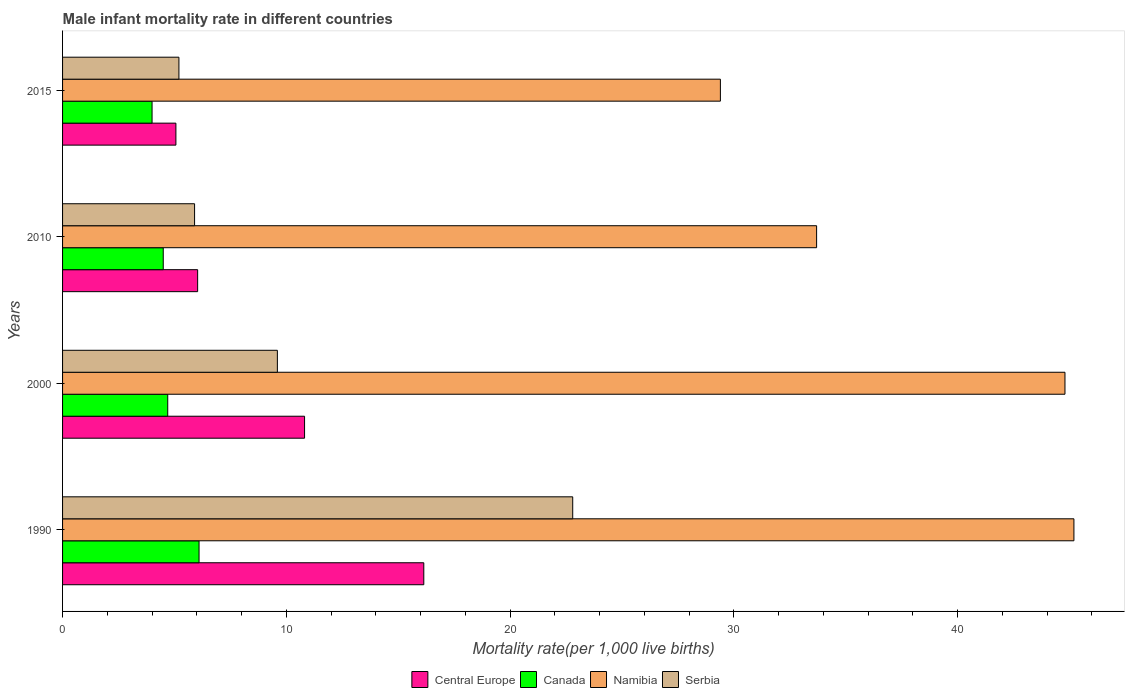How many groups of bars are there?
Make the answer very short. 4. What is the label of the 4th group of bars from the top?
Your response must be concise. 1990. What is the male infant mortality rate in Serbia in 2000?
Give a very brief answer. 9.6. Across all years, what is the maximum male infant mortality rate in Central Europe?
Provide a short and direct response. 16.14. Across all years, what is the minimum male infant mortality rate in Namibia?
Your response must be concise. 29.4. In which year was the male infant mortality rate in Namibia minimum?
Give a very brief answer. 2015. What is the total male infant mortality rate in Canada in the graph?
Your answer should be very brief. 19.3. What is the difference between the male infant mortality rate in Serbia in 2000 and that in 2015?
Provide a short and direct response. 4.4. What is the average male infant mortality rate in Serbia per year?
Ensure brevity in your answer.  10.88. In the year 2000, what is the difference between the male infant mortality rate in Serbia and male infant mortality rate in Namibia?
Your answer should be compact. -35.2. What is the ratio of the male infant mortality rate in Namibia in 1990 to that in 2000?
Your answer should be very brief. 1.01. Is the difference between the male infant mortality rate in Serbia in 1990 and 2015 greater than the difference between the male infant mortality rate in Namibia in 1990 and 2015?
Make the answer very short. Yes. What is the difference between the highest and the second highest male infant mortality rate in Central Europe?
Provide a succinct answer. 5.33. What is the difference between the highest and the lowest male infant mortality rate in Canada?
Make the answer very short. 2.1. Is the sum of the male infant mortality rate in Namibia in 1990 and 2000 greater than the maximum male infant mortality rate in Serbia across all years?
Provide a short and direct response. Yes. What does the 4th bar from the top in 2000 represents?
Offer a terse response. Central Europe. What does the 4th bar from the bottom in 2015 represents?
Provide a succinct answer. Serbia. How many bars are there?
Ensure brevity in your answer.  16. What is the difference between two consecutive major ticks on the X-axis?
Give a very brief answer. 10. Are the values on the major ticks of X-axis written in scientific E-notation?
Your answer should be compact. No. How many legend labels are there?
Provide a succinct answer. 4. What is the title of the graph?
Offer a very short reply. Male infant mortality rate in different countries. What is the label or title of the X-axis?
Provide a succinct answer. Mortality rate(per 1,0 live births). What is the label or title of the Y-axis?
Your response must be concise. Years. What is the Mortality rate(per 1,000 live births) in Central Europe in 1990?
Your answer should be very brief. 16.14. What is the Mortality rate(per 1,000 live births) of Namibia in 1990?
Provide a succinct answer. 45.2. What is the Mortality rate(per 1,000 live births) in Serbia in 1990?
Provide a succinct answer. 22.8. What is the Mortality rate(per 1,000 live births) in Central Europe in 2000?
Make the answer very short. 10.82. What is the Mortality rate(per 1,000 live births) in Canada in 2000?
Make the answer very short. 4.7. What is the Mortality rate(per 1,000 live births) in Namibia in 2000?
Give a very brief answer. 44.8. What is the Mortality rate(per 1,000 live births) in Serbia in 2000?
Offer a very short reply. 9.6. What is the Mortality rate(per 1,000 live births) in Central Europe in 2010?
Make the answer very short. 6.04. What is the Mortality rate(per 1,000 live births) of Namibia in 2010?
Keep it short and to the point. 33.7. What is the Mortality rate(per 1,000 live births) of Serbia in 2010?
Ensure brevity in your answer.  5.9. What is the Mortality rate(per 1,000 live births) of Central Europe in 2015?
Offer a very short reply. 5.07. What is the Mortality rate(per 1,000 live births) of Namibia in 2015?
Ensure brevity in your answer.  29.4. What is the Mortality rate(per 1,000 live births) of Serbia in 2015?
Make the answer very short. 5.2. Across all years, what is the maximum Mortality rate(per 1,000 live births) in Central Europe?
Ensure brevity in your answer.  16.14. Across all years, what is the maximum Mortality rate(per 1,000 live births) of Canada?
Ensure brevity in your answer.  6.1. Across all years, what is the maximum Mortality rate(per 1,000 live births) of Namibia?
Your answer should be compact. 45.2. Across all years, what is the maximum Mortality rate(per 1,000 live births) in Serbia?
Your answer should be very brief. 22.8. Across all years, what is the minimum Mortality rate(per 1,000 live births) in Central Europe?
Provide a succinct answer. 5.07. Across all years, what is the minimum Mortality rate(per 1,000 live births) of Namibia?
Make the answer very short. 29.4. What is the total Mortality rate(per 1,000 live births) in Central Europe in the graph?
Ensure brevity in your answer.  38.06. What is the total Mortality rate(per 1,000 live births) in Canada in the graph?
Your answer should be very brief. 19.3. What is the total Mortality rate(per 1,000 live births) of Namibia in the graph?
Your answer should be compact. 153.1. What is the total Mortality rate(per 1,000 live births) in Serbia in the graph?
Make the answer very short. 43.5. What is the difference between the Mortality rate(per 1,000 live births) in Central Europe in 1990 and that in 2000?
Ensure brevity in your answer.  5.33. What is the difference between the Mortality rate(per 1,000 live births) of Canada in 1990 and that in 2000?
Keep it short and to the point. 1.4. What is the difference between the Mortality rate(per 1,000 live births) in Central Europe in 1990 and that in 2010?
Keep it short and to the point. 10.11. What is the difference between the Mortality rate(per 1,000 live births) in Canada in 1990 and that in 2010?
Provide a short and direct response. 1.6. What is the difference between the Mortality rate(per 1,000 live births) in Namibia in 1990 and that in 2010?
Offer a very short reply. 11.5. What is the difference between the Mortality rate(per 1,000 live births) in Serbia in 1990 and that in 2010?
Make the answer very short. 16.9. What is the difference between the Mortality rate(per 1,000 live births) in Central Europe in 1990 and that in 2015?
Give a very brief answer. 11.08. What is the difference between the Mortality rate(per 1,000 live births) in Serbia in 1990 and that in 2015?
Ensure brevity in your answer.  17.6. What is the difference between the Mortality rate(per 1,000 live births) of Central Europe in 2000 and that in 2010?
Your response must be concise. 4.78. What is the difference between the Mortality rate(per 1,000 live births) in Canada in 2000 and that in 2010?
Ensure brevity in your answer.  0.2. What is the difference between the Mortality rate(per 1,000 live births) of Namibia in 2000 and that in 2010?
Your answer should be very brief. 11.1. What is the difference between the Mortality rate(per 1,000 live births) in Serbia in 2000 and that in 2010?
Ensure brevity in your answer.  3.7. What is the difference between the Mortality rate(per 1,000 live births) of Central Europe in 2000 and that in 2015?
Give a very brief answer. 5.75. What is the difference between the Mortality rate(per 1,000 live births) of Canada in 2000 and that in 2015?
Your response must be concise. 0.7. What is the difference between the Mortality rate(per 1,000 live births) of Namibia in 2000 and that in 2015?
Provide a succinct answer. 15.4. What is the difference between the Mortality rate(per 1,000 live births) in Serbia in 2000 and that in 2015?
Your answer should be very brief. 4.4. What is the difference between the Mortality rate(per 1,000 live births) in Central Europe in 2010 and that in 2015?
Offer a very short reply. 0.97. What is the difference between the Mortality rate(per 1,000 live births) of Central Europe in 1990 and the Mortality rate(per 1,000 live births) of Canada in 2000?
Ensure brevity in your answer.  11.44. What is the difference between the Mortality rate(per 1,000 live births) in Central Europe in 1990 and the Mortality rate(per 1,000 live births) in Namibia in 2000?
Give a very brief answer. -28.66. What is the difference between the Mortality rate(per 1,000 live births) of Central Europe in 1990 and the Mortality rate(per 1,000 live births) of Serbia in 2000?
Your answer should be very brief. 6.54. What is the difference between the Mortality rate(per 1,000 live births) of Canada in 1990 and the Mortality rate(per 1,000 live births) of Namibia in 2000?
Offer a very short reply. -38.7. What is the difference between the Mortality rate(per 1,000 live births) in Namibia in 1990 and the Mortality rate(per 1,000 live births) in Serbia in 2000?
Keep it short and to the point. 35.6. What is the difference between the Mortality rate(per 1,000 live births) of Central Europe in 1990 and the Mortality rate(per 1,000 live births) of Canada in 2010?
Provide a succinct answer. 11.64. What is the difference between the Mortality rate(per 1,000 live births) in Central Europe in 1990 and the Mortality rate(per 1,000 live births) in Namibia in 2010?
Give a very brief answer. -17.56. What is the difference between the Mortality rate(per 1,000 live births) in Central Europe in 1990 and the Mortality rate(per 1,000 live births) in Serbia in 2010?
Offer a very short reply. 10.24. What is the difference between the Mortality rate(per 1,000 live births) in Canada in 1990 and the Mortality rate(per 1,000 live births) in Namibia in 2010?
Keep it short and to the point. -27.6. What is the difference between the Mortality rate(per 1,000 live births) of Namibia in 1990 and the Mortality rate(per 1,000 live births) of Serbia in 2010?
Offer a very short reply. 39.3. What is the difference between the Mortality rate(per 1,000 live births) of Central Europe in 1990 and the Mortality rate(per 1,000 live births) of Canada in 2015?
Your answer should be very brief. 12.14. What is the difference between the Mortality rate(per 1,000 live births) of Central Europe in 1990 and the Mortality rate(per 1,000 live births) of Namibia in 2015?
Ensure brevity in your answer.  -13.26. What is the difference between the Mortality rate(per 1,000 live births) of Central Europe in 1990 and the Mortality rate(per 1,000 live births) of Serbia in 2015?
Give a very brief answer. 10.94. What is the difference between the Mortality rate(per 1,000 live births) of Canada in 1990 and the Mortality rate(per 1,000 live births) of Namibia in 2015?
Offer a terse response. -23.3. What is the difference between the Mortality rate(per 1,000 live births) of Central Europe in 2000 and the Mortality rate(per 1,000 live births) of Canada in 2010?
Your answer should be compact. 6.32. What is the difference between the Mortality rate(per 1,000 live births) of Central Europe in 2000 and the Mortality rate(per 1,000 live births) of Namibia in 2010?
Give a very brief answer. -22.88. What is the difference between the Mortality rate(per 1,000 live births) of Central Europe in 2000 and the Mortality rate(per 1,000 live births) of Serbia in 2010?
Keep it short and to the point. 4.92. What is the difference between the Mortality rate(per 1,000 live births) in Canada in 2000 and the Mortality rate(per 1,000 live births) in Serbia in 2010?
Provide a short and direct response. -1.2. What is the difference between the Mortality rate(per 1,000 live births) in Namibia in 2000 and the Mortality rate(per 1,000 live births) in Serbia in 2010?
Your answer should be compact. 38.9. What is the difference between the Mortality rate(per 1,000 live births) of Central Europe in 2000 and the Mortality rate(per 1,000 live births) of Canada in 2015?
Provide a succinct answer. 6.82. What is the difference between the Mortality rate(per 1,000 live births) of Central Europe in 2000 and the Mortality rate(per 1,000 live births) of Namibia in 2015?
Offer a terse response. -18.58. What is the difference between the Mortality rate(per 1,000 live births) of Central Europe in 2000 and the Mortality rate(per 1,000 live births) of Serbia in 2015?
Your answer should be very brief. 5.62. What is the difference between the Mortality rate(per 1,000 live births) in Canada in 2000 and the Mortality rate(per 1,000 live births) in Namibia in 2015?
Offer a terse response. -24.7. What is the difference between the Mortality rate(per 1,000 live births) of Namibia in 2000 and the Mortality rate(per 1,000 live births) of Serbia in 2015?
Keep it short and to the point. 39.6. What is the difference between the Mortality rate(per 1,000 live births) in Central Europe in 2010 and the Mortality rate(per 1,000 live births) in Canada in 2015?
Provide a short and direct response. 2.04. What is the difference between the Mortality rate(per 1,000 live births) of Central Europe in 2010 and the Mortality rate(per 1,000 live births) of Namibia in 2015?
Give a very brief answer. -23.36. What is the difference between the Mortality rate(per 1,000 live births) of Central Europe in 2010 and the Mortality rate(per 1,000 live births) of Serbia in 2015?
Give a very brief answer. 0.84. What is the difference between the Mortality rate(per 1,000 live births) of Canada in 2010 and the Mortality rate(per 1,000 live births) of Namibia in 2015?
Keep it short and to the point. -24.9. What is the difference between the Mortality rate(per 1,000 live births) of Namibia in 2010 and the Mortality rate(per 1,000 live births) of Serbia in 2015?
Your answer should be compact. 28.5. What is the average Mortality rate(per 1,000 live births) in Central Europe per year?
Offer a very short reply. 9.52. What is the average Mortality rate(per 1,000 live births) in Canada per year?
Make the answer very short. 4.83. What is the average Mortality rate(per 1,000 live births) of Namibia per year?
Keep it short and to the point. 38.27. What is the average Mortality rate(per 1,000 live births) in Serbia per year?
Keep it short and to the point. 10.88. In the year 1990, what is the difference between the Mortality rate(per 1,000 live births) of Central Europe and Mortality rate(per 1,000 live births) of Canada?
Your response must be concise. 10.04. In the year 1990, what is the difference between the Mortality rate(per 1,000 live births) of Central Europe and Mortality rate(per 1,000 live births) of Namibia?
Give a very brief answer. -29.06. In the year 1990, what is the difference between the Mortality rate(per 1,000 live births) of Central Europe and Mortality rate(per 1,000 live births) of Serbia?
Provide a succinct answer. -6.66. In the year 1990, what is the difference between the Mortality rate(per 1,000 live births) of Canada and Mortality rate(per 1,000 live births) of Namibia?
Provide a succinct answer. -39.1. In the year 1990, what is the difference between the Mortality rate(per 1,000 live births) in Canada and Mortality rate(per 1,000 live births) in Serbia?
Offer a terse response. -16.7. In the year 1990, what is the difference between the Mortality rate(per 1,000 live births) in Namibia and Mortality rate(per 1,000 live births) in Serbia?
Offer a very short reply. 22.4. In the year 2000, what is the difference between the Mortality rate(per 1,000 live births) of Central Europe and Mortality rate(per 1,000 live births) of Canada?
Give a very brief answer. 6.12. In the year 2000, what is the difference between the Mortality rate(per 1,000 live births) in Central Europe and Mortality rate(per 1,000 live births) in Namibia?
Provide a short and direct response. -33.98. In the year 2000, what is the difference between the Mortality rate(per 1,000 live births) of Central Europe and Mortality rate(per 1,000 live births) of Serbia?
Offer a terse response. 1.22. In the year 2000, what is the difference between the Mortality rate(per 1,000 live births) in Canada and Mortality rate(per 1,000 live births) in Namibia?
Provide a succinct answer. -40.1. In the year 2000, what is the difference between the Mortality rate(per 1,000 live births) in Canada and Mortality rate(per 1,000 live births) in Serbia?
Make the answer very short. -4.9. In the year 2000, what is the difference between the Mortality rate(per 1,000 live births) in Namibia and Mortality rate(per 1,000 live births) in Serbia?
Offer a very short reply. 35.2. In the year 2010, what is the difference between the Mortality rate(per 1,000 live births) in Central Europe and Mortality rate(per 1,000 live births) in Canada?
Make the answer very short. 1.54. In the year 2010, what is the difference between the Mortality rate(per 1,000 live births) of Central Europe and Mortality rate(per 1,000 live births) of Namibia?
Your answer should be compact. -27.66. In the year 2010, what is the difference between the Mortality rate(per 1,000 live births) in Central Europe and Mortality rate(per 1,000 live births) in Serbia?
Your response must be concise. 0.14. In the year 2010, what is the difference between the Mortality rate(per 1,000 live births) of Canada and Mortality rate(per 1,000 live births) of Namibia?
Give a very brief answer. -29.2. In the year 2010, what is the difference between the Mortality rate(per 1,000 live births) in Canada and Mortality rate(per 1,000 live births) in Serbia?
Make the answer very short. -1.4. In the year 2010, what is the difference between the Mortality rate(per 1,000 live births) of Namibia and Mortality rate(per 1,000 live births) of Serbia?
Ensure brevity in your answer.  27.8. In the year 2015, what is the difference between the Mortality rate(per 1,000 live births) of Central Europe and Mortality rate(per 1,000 live births) of Canada?
Provide a succinct answer. 1.07. In the year 2015, what is the difference between the Mortality rate(per 1,000 live births) in Central Europe and Mortality rate(per 1,000 live births) in Namibia?
Offer a terse response. -24.33. In the year 2015, what is the difference between the Mortality rate(per 1,000 live births) in Central Europe and Mortality rate(per 1,000 live births) in Serbia?
Give a very brief answer. -0.13. In the year 2015, what is the difference between the Mortality rate(per 1,000 live births) of Canada and Mortality rate(per 1,000 live births) of Namibia?
Your answer should be compact. -25.4. In the year 2015, what is the difference between the Mortality rate(per 1,000 live births) of Namibia and Mortality rate(per 1,000 live births) of Serbia?
Your answer should be compact. 24.2. What is the ratio of the Mortality rate(per 1,000 live births) in Central Europe in 1990 to that in 2000?
Keep it short and to the point. 1.49. What is the ratio of the Mortality rate(per 1,000 live births) of Canada in 1990 to that in 2000?
Make the answer very short. 1.3. What is the ratio of the Mortality rate(per 1,000 live births) of Namibia in 1990 to that in 2000?
Offer a terse response. 1.01. What is the ratio of the Mortality rate(per 1,000 live births) of Serbia in 1990 to that in 2000?
Your answer should be compact. 2.38. What is the ratio of the Mortality rate(per 1,000 live births) of Central Europe in 1990 to that in 2010?
Your answer should be very brief. 2.67. What is the ratio of the Mortality rate(per 1,000 live births) in Canada in 1990 to that in 2010?
Ensure brevity in your answer.  1.36. What is the ratio of the Mortality rate(per 1,000 live births) in Namibia in 1990 to that in 2010?
Keep it short and to the point. 1.34. What is the ratio of the Mortality rate(per 1,000 live births) in Serbia in 1990 to that in 2010?
Offer a very short reply. 3.86. What is the ratio of the Mortality rate(per 1,000 live births) in Central Europe in 1990 to that in 2015?
Give a very brief answer. 3.19. What is the ratio of the Mortality rate(per 1,000 live births) of Canada in 1990 to that in 2015?
Make the answer very short. 1.52. What is the ratio of the Mortality rate(per 1,000 live births) in Namibia in 1990 to that in 2015?
Offer a terse response. 1.54. What is the ratio of the Mortality rate(per 1,000 live births) of Serbia in 1990 to that in 2015?
Ensure brevity in your answer.  4.38. What is the ratio of the Mortality rate(per 1,000 live births) in Central Europe in 2000 to that in 2010?
Your answer should be very brief. 1.79. What is the ratio of the Mortality rate(per 1,000 live births) in Canada in 2000 to that in 2010?
Keep it short and to the point. 1.04. What is the ratio of the Mortality rate(per 1,000 live births) of Namibia in 2000 to that in 2010?
Ensure brevity in your answer.  1.33. What is the ratio of the Mortality rate(per 1,000 live births) of Serbia in 2000 to that in 2010?
Your answer should be very brief. 1.63. What is the ratio of the Mortality rate(per 1,000 live births) of Central Europe in 2000 to that in 2015?
Keep it short and to the point. 2.14. What is the ratio of the Mortality rate(per 1,000 live births) in Canada in 2000 to that in 2015?
Your answer should be very brief. 1.18. What is the ratio of the Mortality rate(per 1,000 live births) of Namibia in 2000 to that in 2015?
Ensure brevity in your answer.  1.52. What is the ratio of the Mortality rate(per 1,000 live births) in Serbia in 2000 to that in 2015?
Keep it short and to the point. 1.85. What is the ratio of the Mortality rate(per 1,000 live births) in Central Europe in 2010 to that in 2015?
Keep it short and to the point. 1.19. What is the ratio of the Mortality rate(per 1,000 live births) in Namibia in 2010 to that in 2015?
Your answer should be compact. 1.15. What is the ratio of the Mortality rate(per 1,000 live births) of Serbia in 2010 to that in 2015?
Your answer should be very brief. 1.13. What is the difference between the highest and the second highest Mortality rate(per 1,000 live births) in Central Europe?
Provide a short and direct response. 5.33. What is the difference between the highest and the lowest Mortality rate(per 1,000 live births) of Central Europe?
Give a very brief answer. 11.08. What is the difference between the highest and the lowest Mortality rate(per 1,000 live births) of Namibia?
Your answer should be very brief. 15.8. 